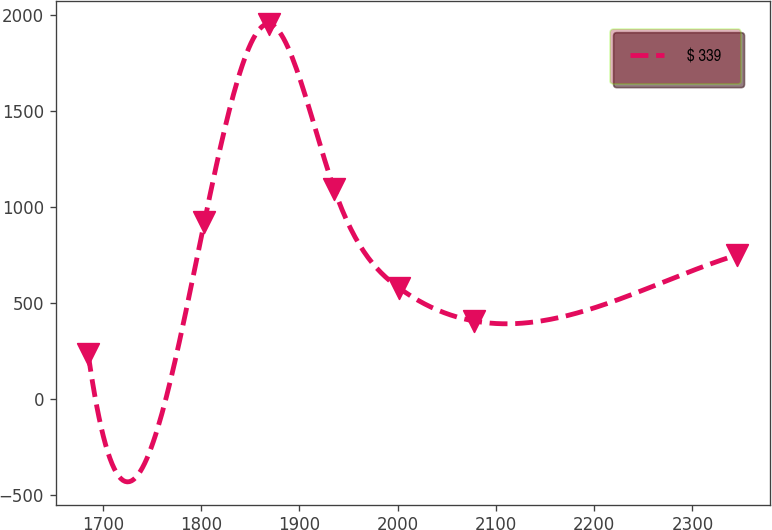<chart> <loc_0><loc_0><loc_500><loc_500><line_chart><ecel><fcel>$ 339<nl><fcel>1684.87<fcel>235.39<nl><fcel>1803.16<fcel>923.47<nl><fcel>1869.22<fcel>1955.62<nl><fcel>1935.28<fcel>1095.49<nl><fcel>2001.34<fcel>579.43<nl><fcel>2077.5<fcel>407.41<nl><fcel>2345.48<fcel>751.45<nl></chart> 